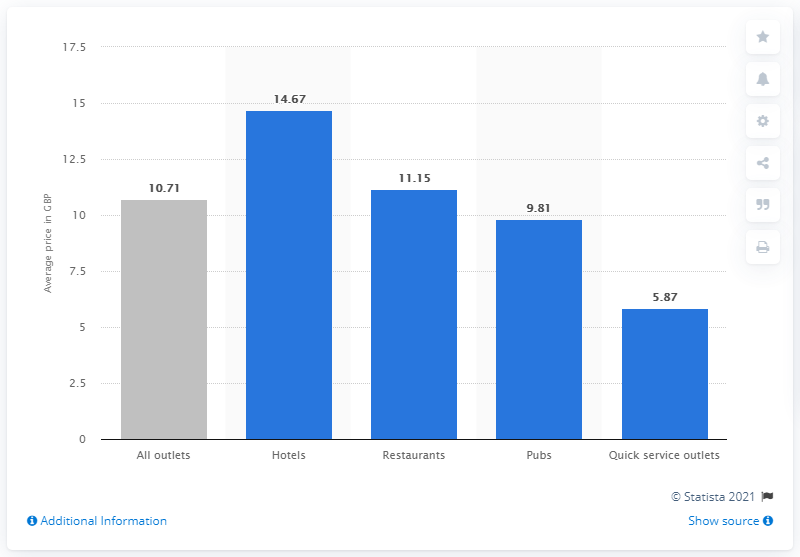Highlight a few significant elements in this photo. According to the data, the average price of a main course eaten out in a hotel is 14.67 euros. 